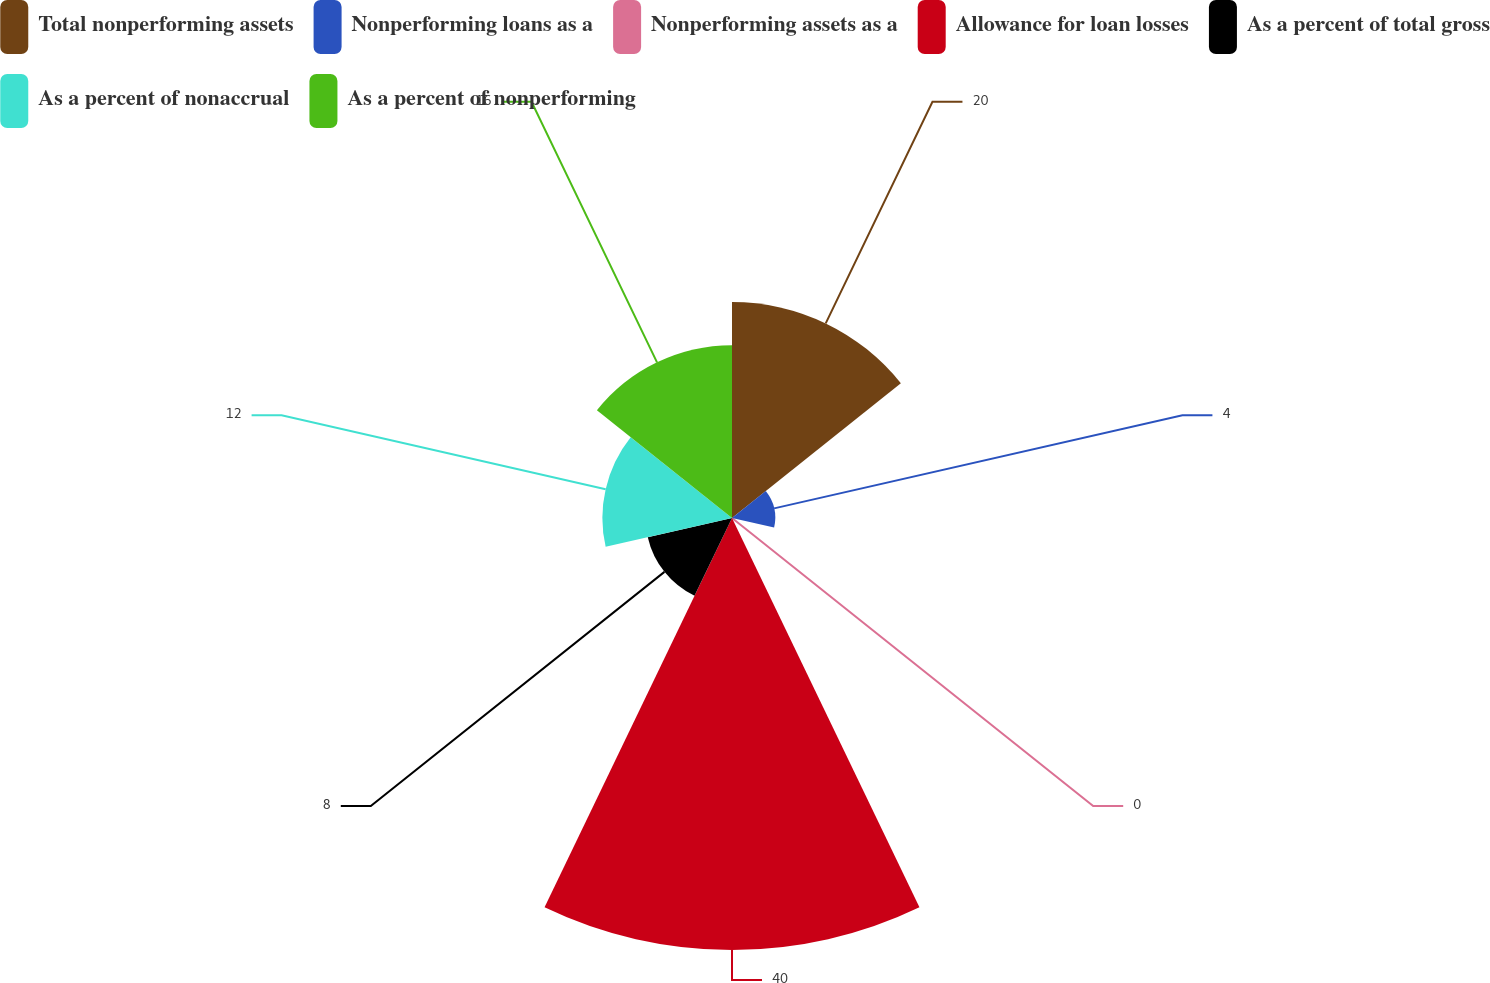<chart> <loc_0><loc_0><loc_500><loc_500><pie_chart><fcel>Total nonperforming assets<fcel>Nonperforming loans as a<fcel>Nonperforming assets as a<fcel>Allowance for loan losses<fcel>As a percent of total gross<fcel>As a percent of nonaccrual<fcel>As a percent of nonperforming<nl><fcel>20.0%<fcel>4.0%<fcel>0.0%<fcel>40.0%<fcel>8.0%<fcel>12.0%<fcel>16.0%<nl></chart> 